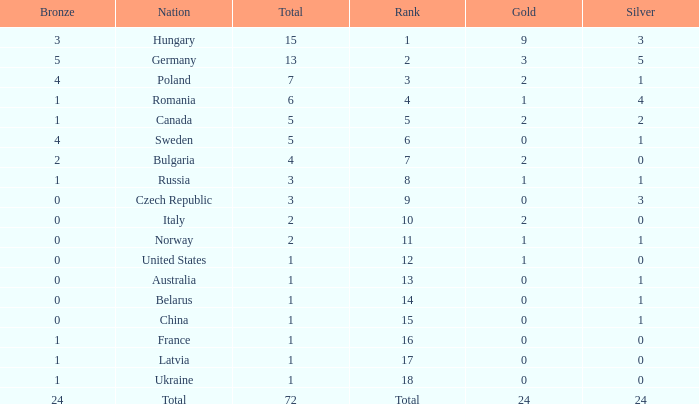How many golds have 3 as the rank, with a total greater than 7? 0.0. 